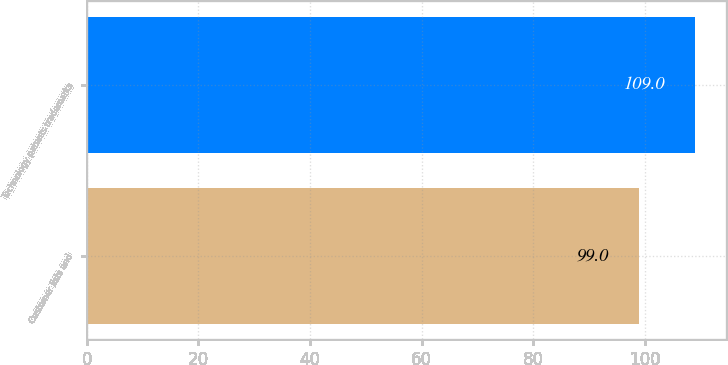Convert chart. <chart><loc_0><loc_0><loc_500><loc_500><bar_chart><fcel>Customer lists and<fcel>Technology patents trademarks<nl><fcel>99<fcel>109<nl></chart> 